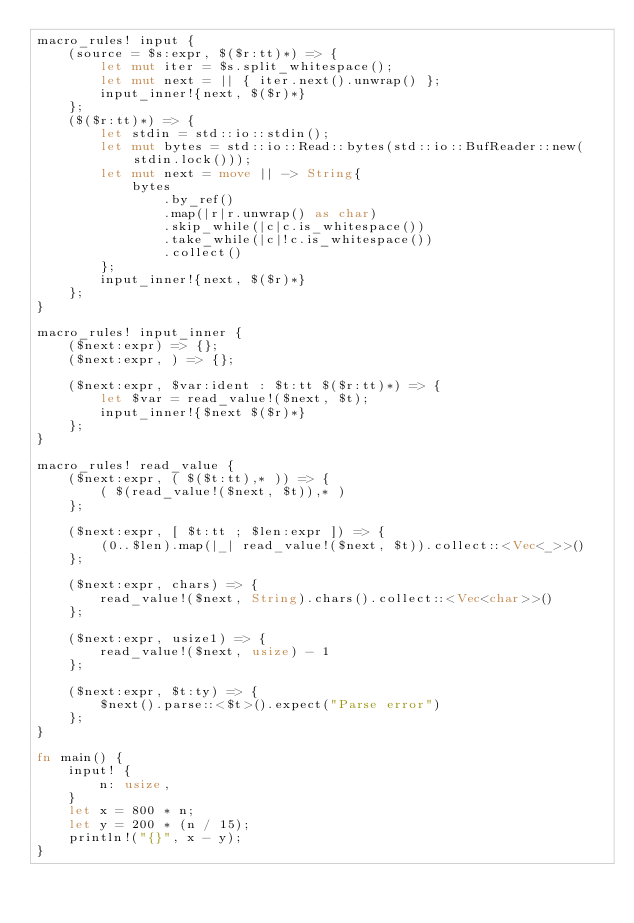<code> <loc_0><loc_0><loc_500><loc_500><_Rust_>macro_rules! input {
    (source = $s:expr, $($r:tt)*) => {
        let mut iter = $s.split_whitespace();
        let mut next = || { iter.next().unwrap() };
        input_inner!{next, $($r)*}
    };
    ($($r:tt)*) => {
        let stdin = std::io::stdin();
        let mut bytes = std::io::Read::bytes(std::io::BufReader::new(stdin.lock()));
        let mut next = move || -> String{
            bytes
                .by_ref()
                .map(|r|r.unwrap() as char)
                .skip_while(|c|c.is_whitespace())
                .take_while(|c|!c.is_whitespace())
                .collect()
        };
        input_inner!{next, $($r)*}
    };
}

macro_rules! input_inner {
    ($next:expr) => {};
    ($next:expr, ) => {};

    ($next:expr, $var:ident : $t:tt $($r:tt)*) => {
        let $var = read_value!($next, $t);
        input_inner!{$next $($r)*}
    };
}

macro_rules! read_value {
    ($next:expr, ( $($t:tt),* )) => {
        ( $(read_value!($next, $t)),* )
    };

    ($next:expr, [ $t:tt ; $len:expr ]) => {
        (0..$len).map(|_| read_value!($next, $t)).collect::<Vec<_>>()
    };

    ($next:expr, chars) => {
        read_value!($next, String).chars().collect::<Vec<char>>()
    };

    ($next:expr, usize1) => {
        read_value!($next, usize) - 1
    };

    ($next:expr, $t:ty) => {
        $next().parse::<$t>().expect("Parse error")
    };
}

fn main() {
    input! {
        n: usize,
    }
    let x = 800 * n;
    let y = 200 * (n / 15);
    println!("{}", x - y);
}
</code> 